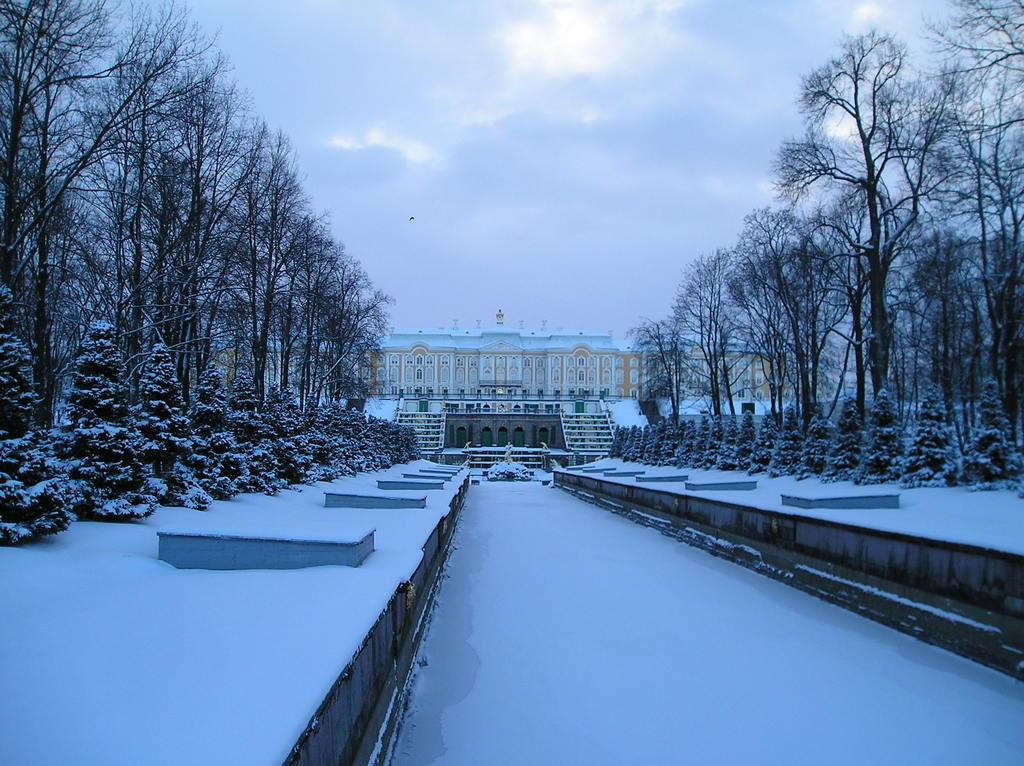What is there is a structure visible in the image, what is it? There is there a building in the image? What else can be seen in the image besides the building? There are trees in the image. How is the ground depicted in the image? The ground is covered with snow. What is visible in the sky in the image? There are clouds in the sky. What rule is being enforced by the trees in the image? There is no rule being enforced by the trees in the image; they are simply depicted as part of the natural environment. 